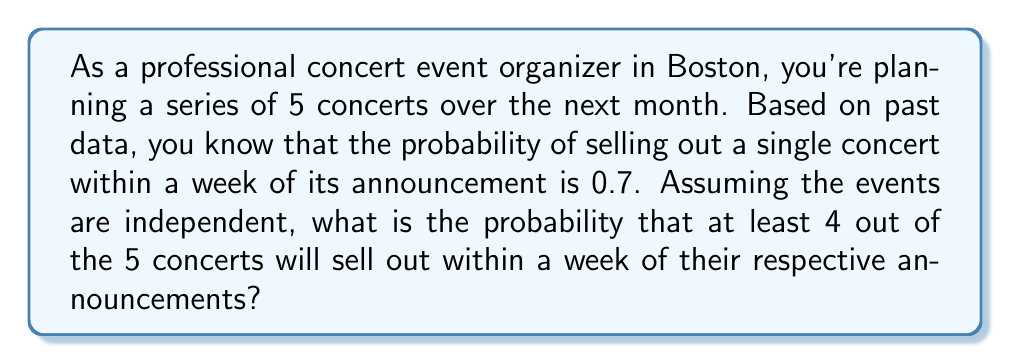Teach me how to tackle this problem. Let's approach this step-by-step using the binomial probability distribution:

1) Let X be the number of concerts that sell out within a week.
2) We want P(X ≥ 4), which is equal to P(X = 4) + P(X = 5).
3) The probability of success (selling out) for each concert is p = 0.7.
4) The probability of failure (not selling out) for each concert is q = 1 - p = 0.3.
5) We have n = 5 concerts in total.

The binomial probability formula is:

$$ P(X = k) = \binom{n}{k} p^k (1-p)^{n-k} $$

For P(X = 4):
$$ P(X = 4) = \binom{5}{4} (0.7)^4 (0.3)^1 $$
$$ = 5 * (0.7)^4 * (0.3) = 5 * 0.2401 * 0.3 = 0.36015 $$

For P(X = 5):
$$ P(X = 5) = \binom{5}{5} (0.7)^5 (0.3)^0 $$
$$ = 1 * (0.7)^5 = 0.16807 $$

Therefore, P(X ≥ 4) = P(X = 4) + P(X = 5) = 0.36015 + 0.16807 = 0.52822
Answer: The probability that at least 4 out of the 5 concerts will sell out within a week of their announcements is approximately 0.52822 or 52.822%. 